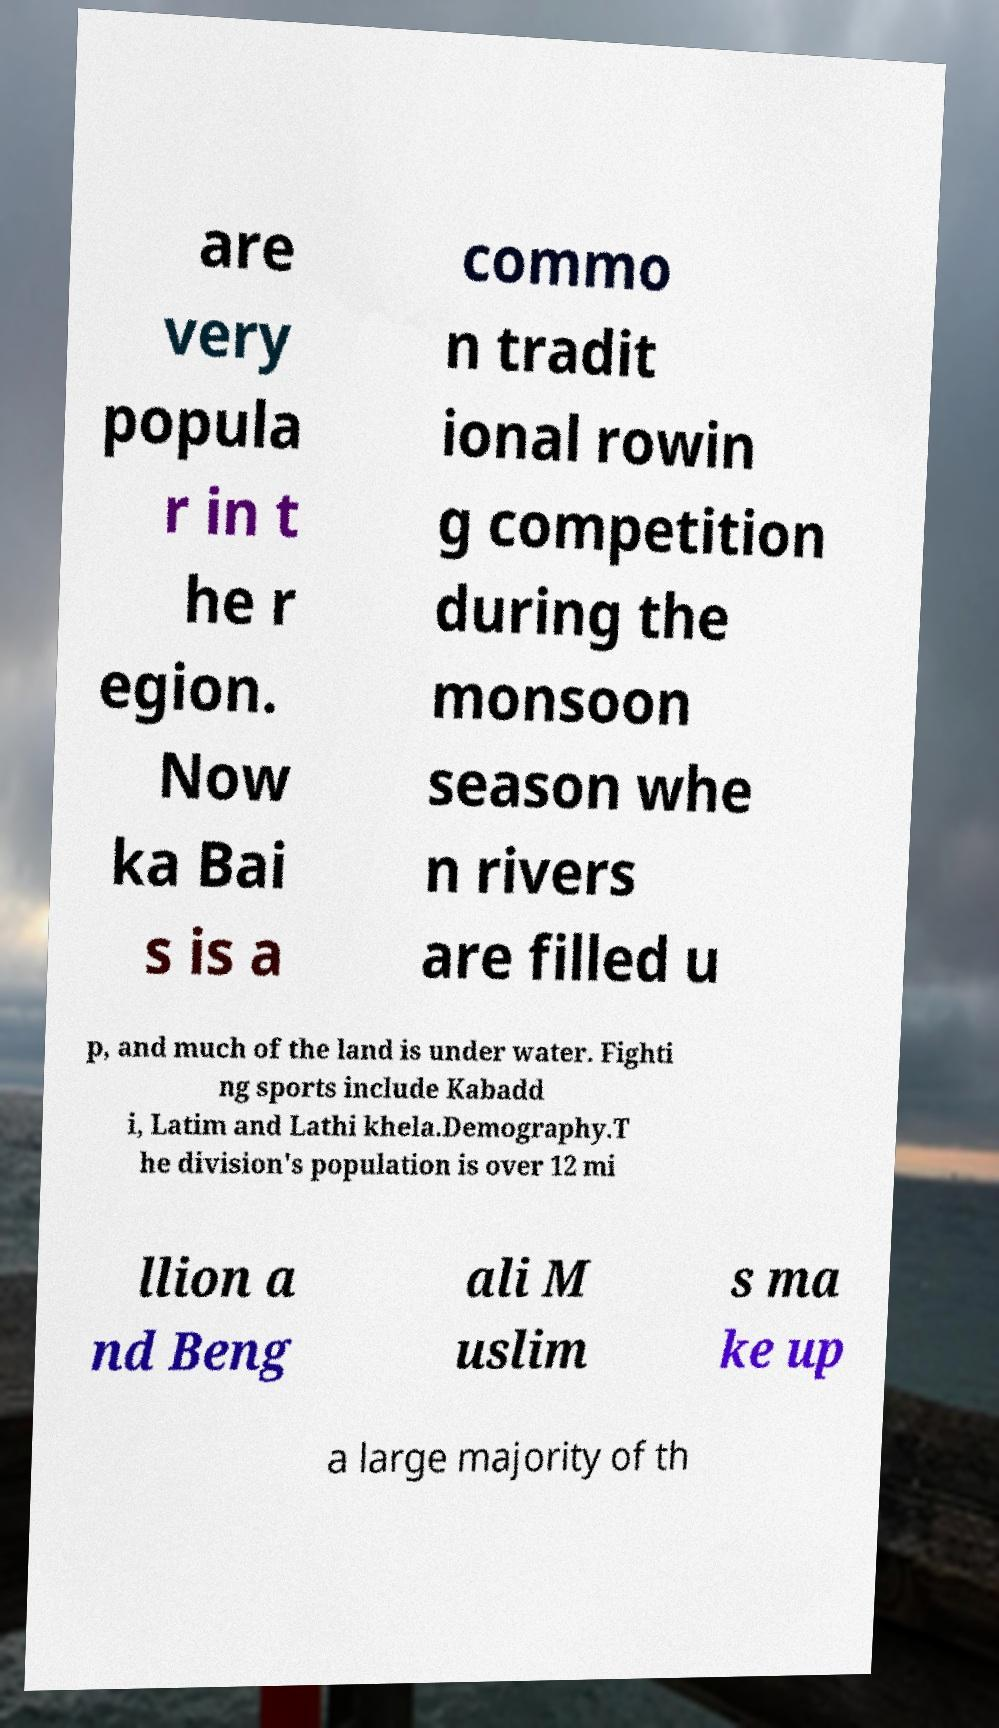There's text embedded in this image that I need extracted. Can you transcribe it verbatim? are very popula r in t he r egion. Now ka Bai s is a commo n tradit ional rowin g competition during the monsoon season whe n rivers are filled u p, and much of the land is under water. Fighti ng sports include Kabadd i, Latim and Lathi khela.Demography.T he division's population is over 12 mi llion a nd Beng ali M uslim s ma ke up a large majority of th 